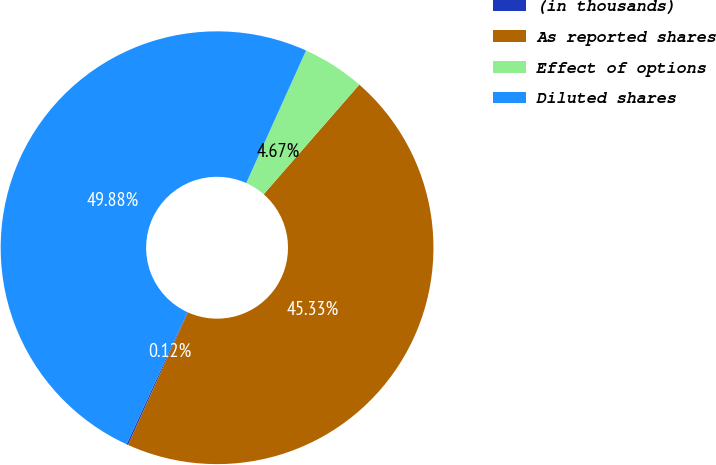Convert chart. <chart><loc_0><loc_0><loc_500><loc_500><pie_chart><fcel>(in thousands)<fcel>As reported shares<fcel>Effect of options<fcel>Diluted shares<nl><fcel>0.12%<fcel>45.33%<fcel>4.67%<fcel>49.88%<nl></chart> 